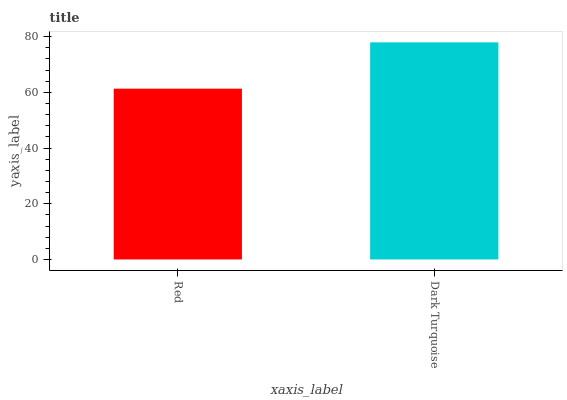Is Red the minimum?
Answer yes or no. Yes. Is Dark Turquoise the maximum?
Answer yes or no. Yes. Is Dark Turquoise the minimum?
Answer yes or no. No. Is Dark Turquoise greater than Red?
Answer yes or no. Yes. Is Red less than Dark Turquoise?
Answer yes or no. Yes. Is Red greater than Dark Turquoise?
Answer yes or no. No. Is Dark Turquoise less than Red?
Answer yes or no. No. Is Dark Turquoise the high median?
Answer yes or no. Yes. Is Red the low median?
Answer yes or no. Yes. Is Red the high median?
Answer yes or no. No. Is Dark Turquoise the low median?
Answer yes or no. No. 